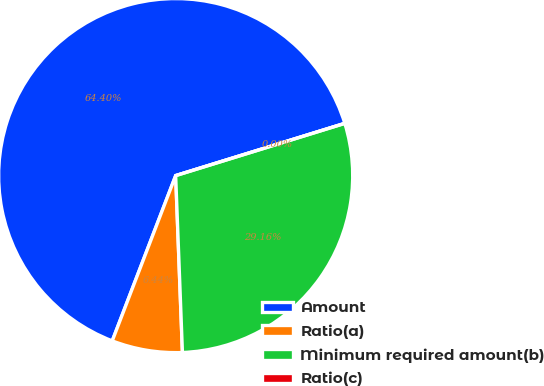<chart> <loc_0><loc_0><loc_500><loc_500><pie_chart><fcel>Amount<fcel>Ratio(a)<fcel>Minimum required amount(b)<fcel>Ratio(c)<nl><fcel>64.4%<fcel>6.44%<fcel>29.16%<fcel>0.0%<nl></chart> 